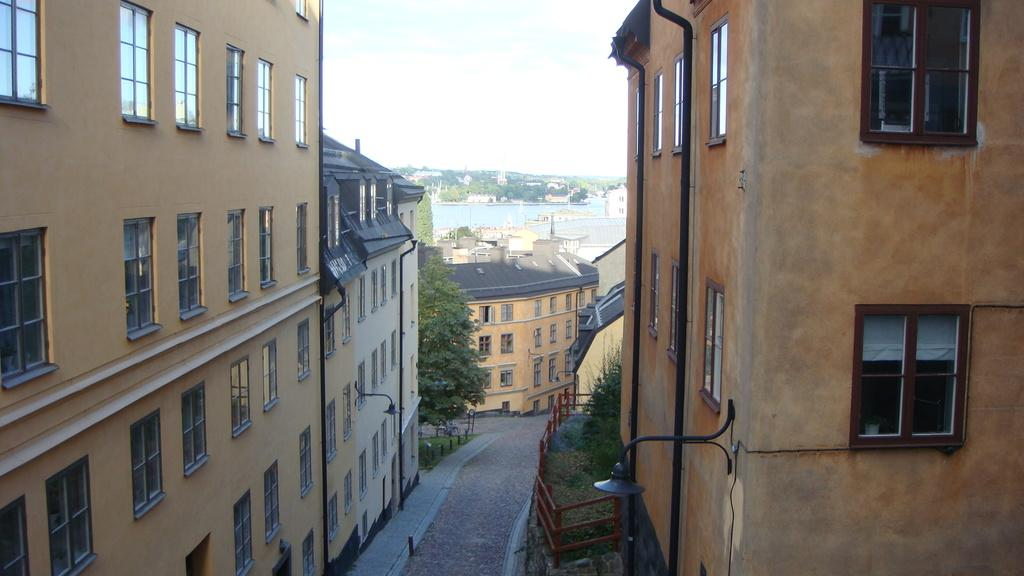What can be seen on both sides of the image? There are buildings and trees on both sides of the image. What separates the two sides in the image? There is a boundary in the image. What is in the middle of the image? There is a path in the middle of the image. What is visible in the background of the image? There is a water body, buildings, and trees in the background of the image. Where are the cherries hanging in the image? There are no cherries present in the image. What color is the shirt worn by the tree in the image? There are no trees wearing shirts in the image; trees are not anthropomorphic. 